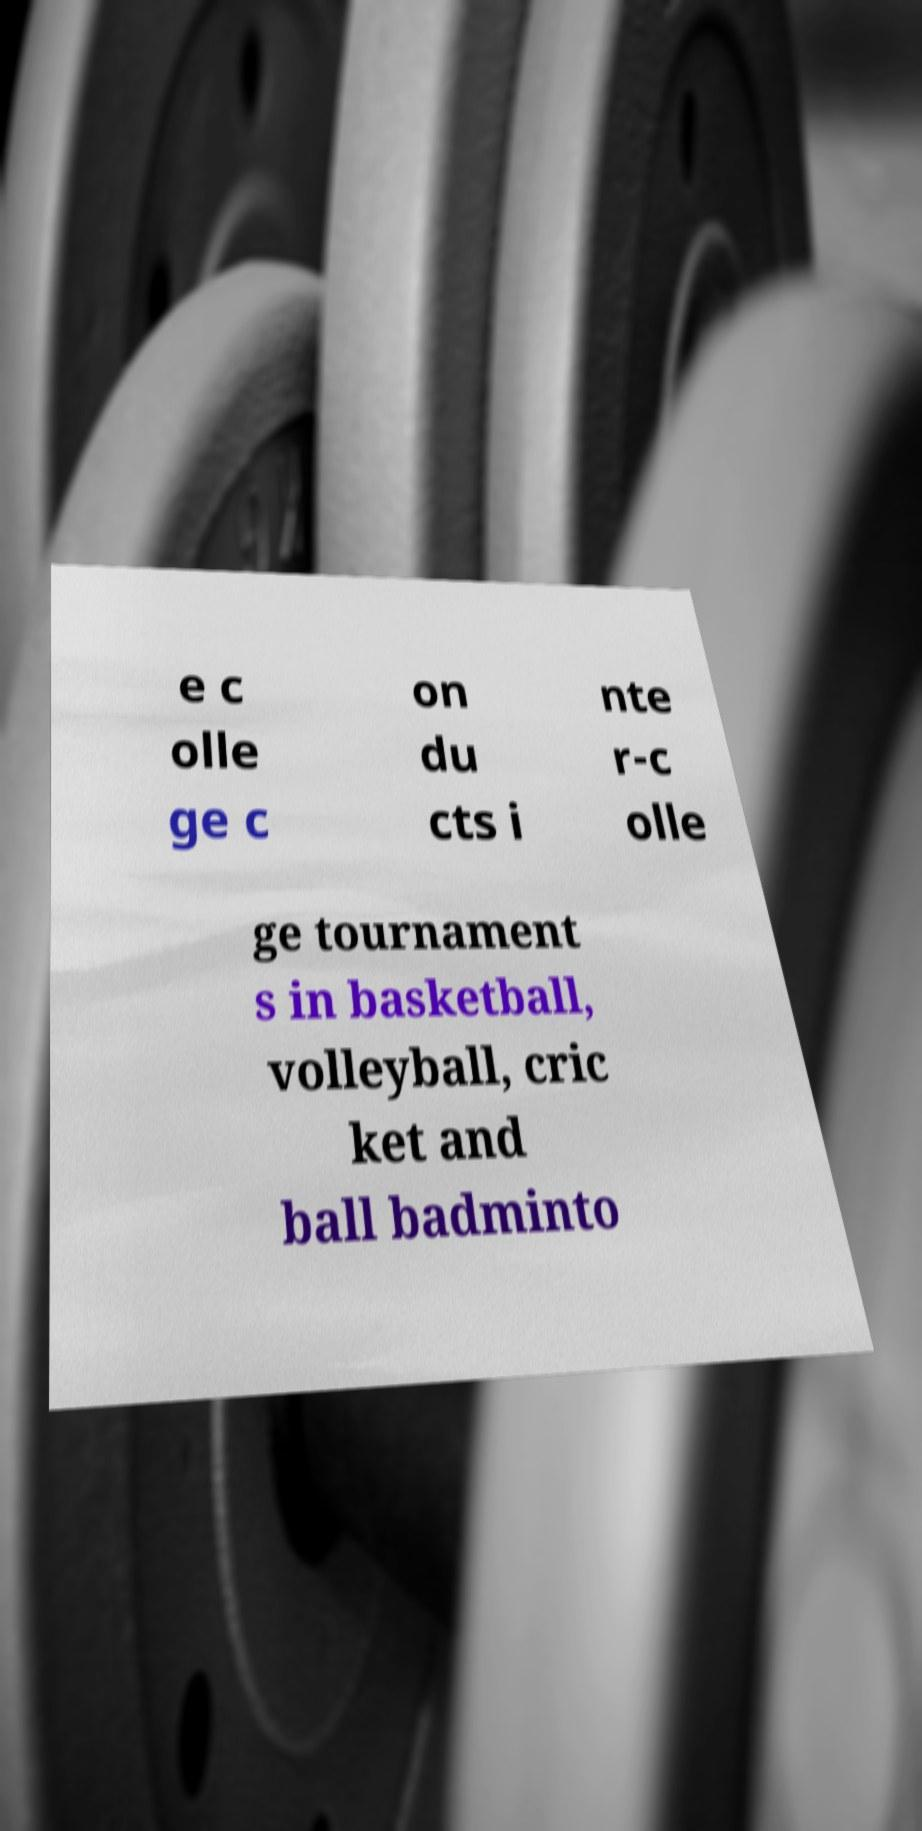Please read and relay the text visible in this image. What does it say? e c olle ge c on du cts i nte r-c olle ge tournament s in basketball, volleyball, cric ket and ball badminto 